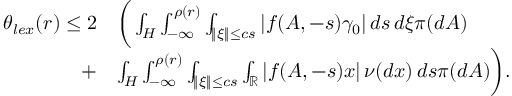Convert formula to latex. <formula><loc_0><loc_0><loc_500><loc_500>\begin{array} { r l } { \theta _ { l e x } ( r ) \leq 2 } & { \left ( \int _ { H } \int _ { - \infty } ^ { \rho ( r ) } \int _ { \| \xi \| \leq c s } | f ( A , - s ) \gamma _ { 0 } | \, d s \, d \xi \pi ( d A ) } \\ { + } & { \int _ { H } \int _ { - \infty } ^ { \rho ( r ) } \int _ { \| \xi \| \leq c s } \int _ { \mathbb { R } } | f ( A , - s ) x | \, \nu ( d x ) \, d s \pi ( d A ) \right ) . } \end{array}</formula> 